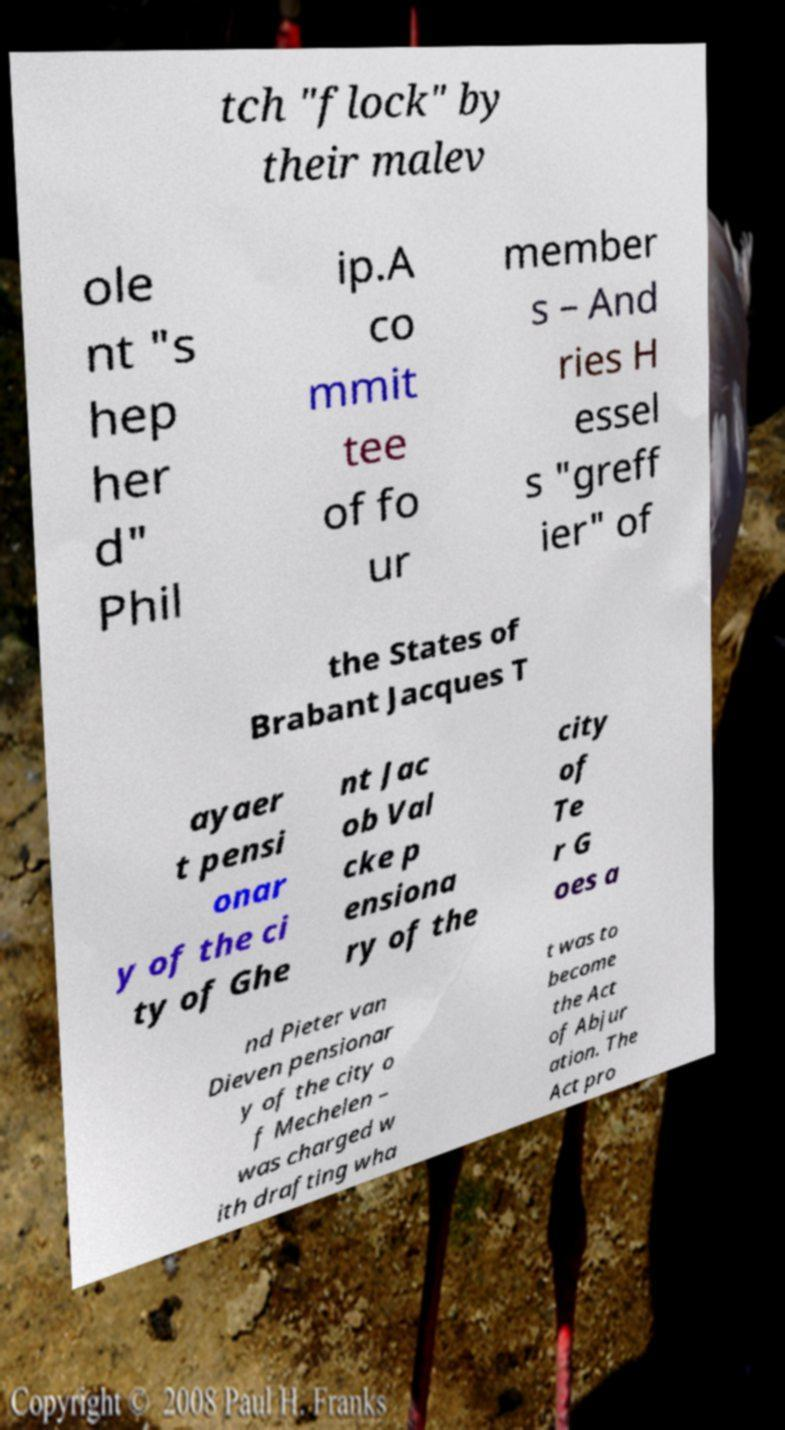Could you extract and type out the text from this image? tch "flock" by their malev ole nt "s hep her d" Phil ip.A co mmit tee of fo ur member s – And ries H essel s "greff ier" of the States of Brabant Jacques T ayaer t pensi onar y of the ci ty of Ghe nt Jac ob Val cke p ensiona ry of the city of Te r G oes a nd Pieter van Dieven pensionar y of the city o f Mechelen – was charged w ith drafting wha t was to become the Act of Abjur ation. The Act pro 